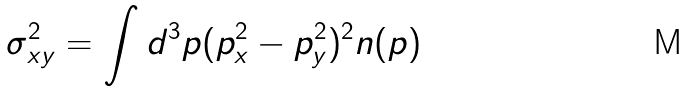<formula> <loc_0><loc_0><loc_500><loc_500>\sigma ^ { 2 } _ { x y } = \int d ^ { 3 } p ( p ^ { 2 } _ { x } - p ^ { 2 } _ { y } ) ^ { 2 } n ( p )</formula> 